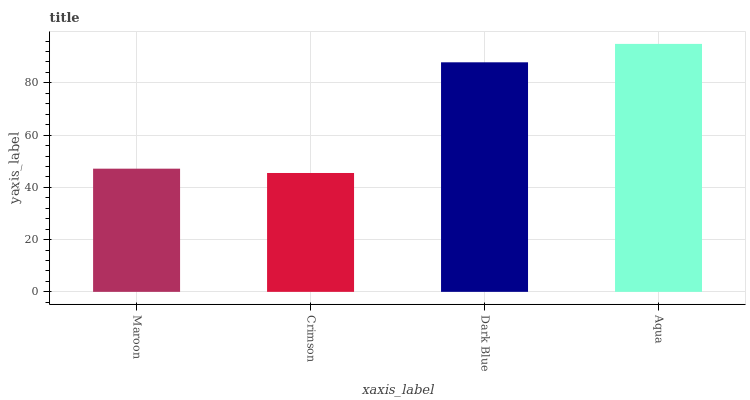Is Dark Blue the minimum?
Answer yes or no. No. Is Dark Blue the maximum?
Answer yes or no. No. Is Dark Blue greater than Crimson?
Answer yes or no. Yes. Is Crimson less than Dark Blue?
Answer yes or no. Yes. Is Crimson greater than Dark Blue?
Answer yes or no. No. Is Dark Blue less than Crimson?
Answer yes or no. No. Is Dark Blue the high median?
Answer yes or no. Yes. Is Maroon the low median?
Answer yes or no. Yes. Is Crimson the high median?
Answer yes or no. No. Is Crimson the low median?
Answer yes or no. No. 